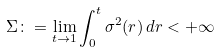Convert formula to latex. <formula><loc_0><loc_0><loc_500><loc_500>\Sigma \colon = \lim _ { t \to 1 } \int _ { 0 } ^ { t } \sigma ^ { 2 } ( r ) \, d r < + \infty</formula> 